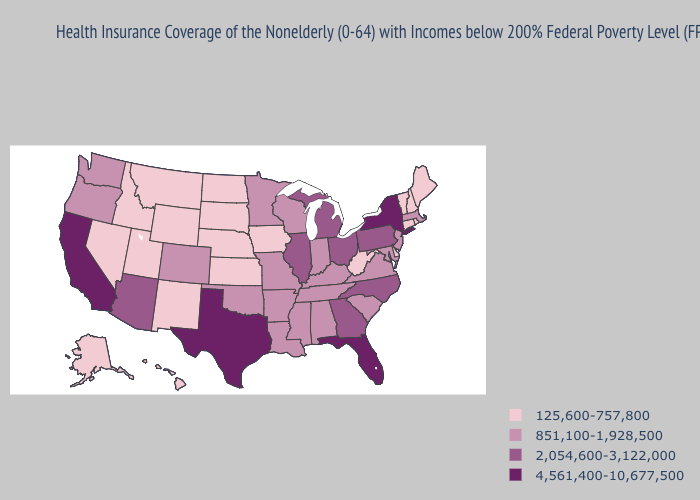Does Alabama have the lowest value in the USA?
Write a very short answer. No. Does Oklahoma have a higher value than Nevada?
Answer briefly. Yes. Among the states that border Wisconsin , does Illinois have the highest value?
Answer briefly. Yes. What is the highest value in states that border Colorado?
Short answer required. 2,054,600-3,122,000. Does North Dakota have the same value as Alaska?
Give a very brief answer. Yes. Name the states that have a value in the range 4,561,400-10,677,500?
Quick response, please. California, Florida, New York, Texas. What is the value of Louisiana?
Concise answer only. 851,100-1,928,500. Does South Dakota have the lowest value in the MidWest?
Quick response, please. Yes. What is the value of Connecticut?
Quick response, please. 125,600-757,800. What is the lowest value in states that border Arizona?
Keep it brief. 125,600-757,800. Does the map have missing data?
Quick response, please. No. Does Utah have the lowest value in the USA?
Concise answer only. Yes. Which states have the lowest value in the USA?
Quick response, please. Alaska, Connecticut, Delaware, Hawaii, Idaho, Iowa, Kansas, Maine, Montana, Nebraska, Nevada, New Hampshire, New Mexico, North Dakota, Rhode Island, South Dakota, Utah, Vermont, West Virginia, Wyoming. Name the states that have a value in the range 125,600-757,800?
Write a very short answer. Alaska, Connecticut, Delaware, Hawaii, Idaho, Iowa, Kansas, Maine, Montana, Nebraska, Nevada, New Hampshire, New Mexico, North Dakota, Rhode Island, South Dakota, Utah, Vermont, West Virginia, Wyoming. Among the states that border Nevada , which have the lowest value?
Give a very brief answer. Idaho, Utah. 